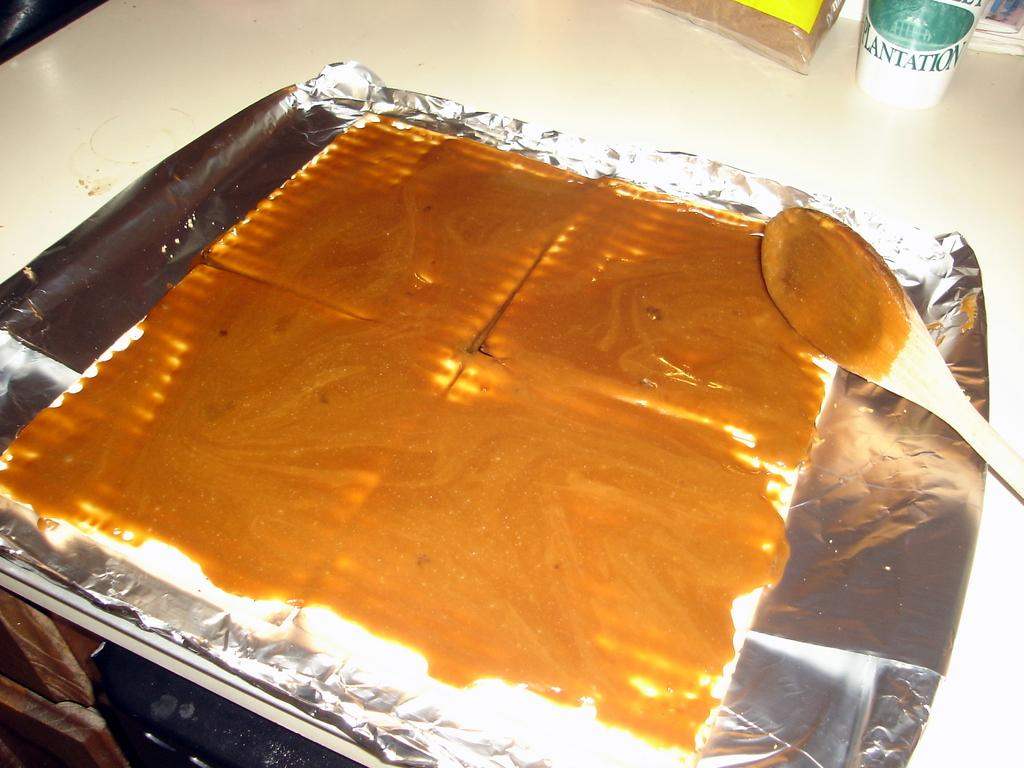<image>
Offer a succinct explanation of the picture presented. A cup with the word "Plantation" on it sits on the counter behind some type of food being prepared on tinfoil. 